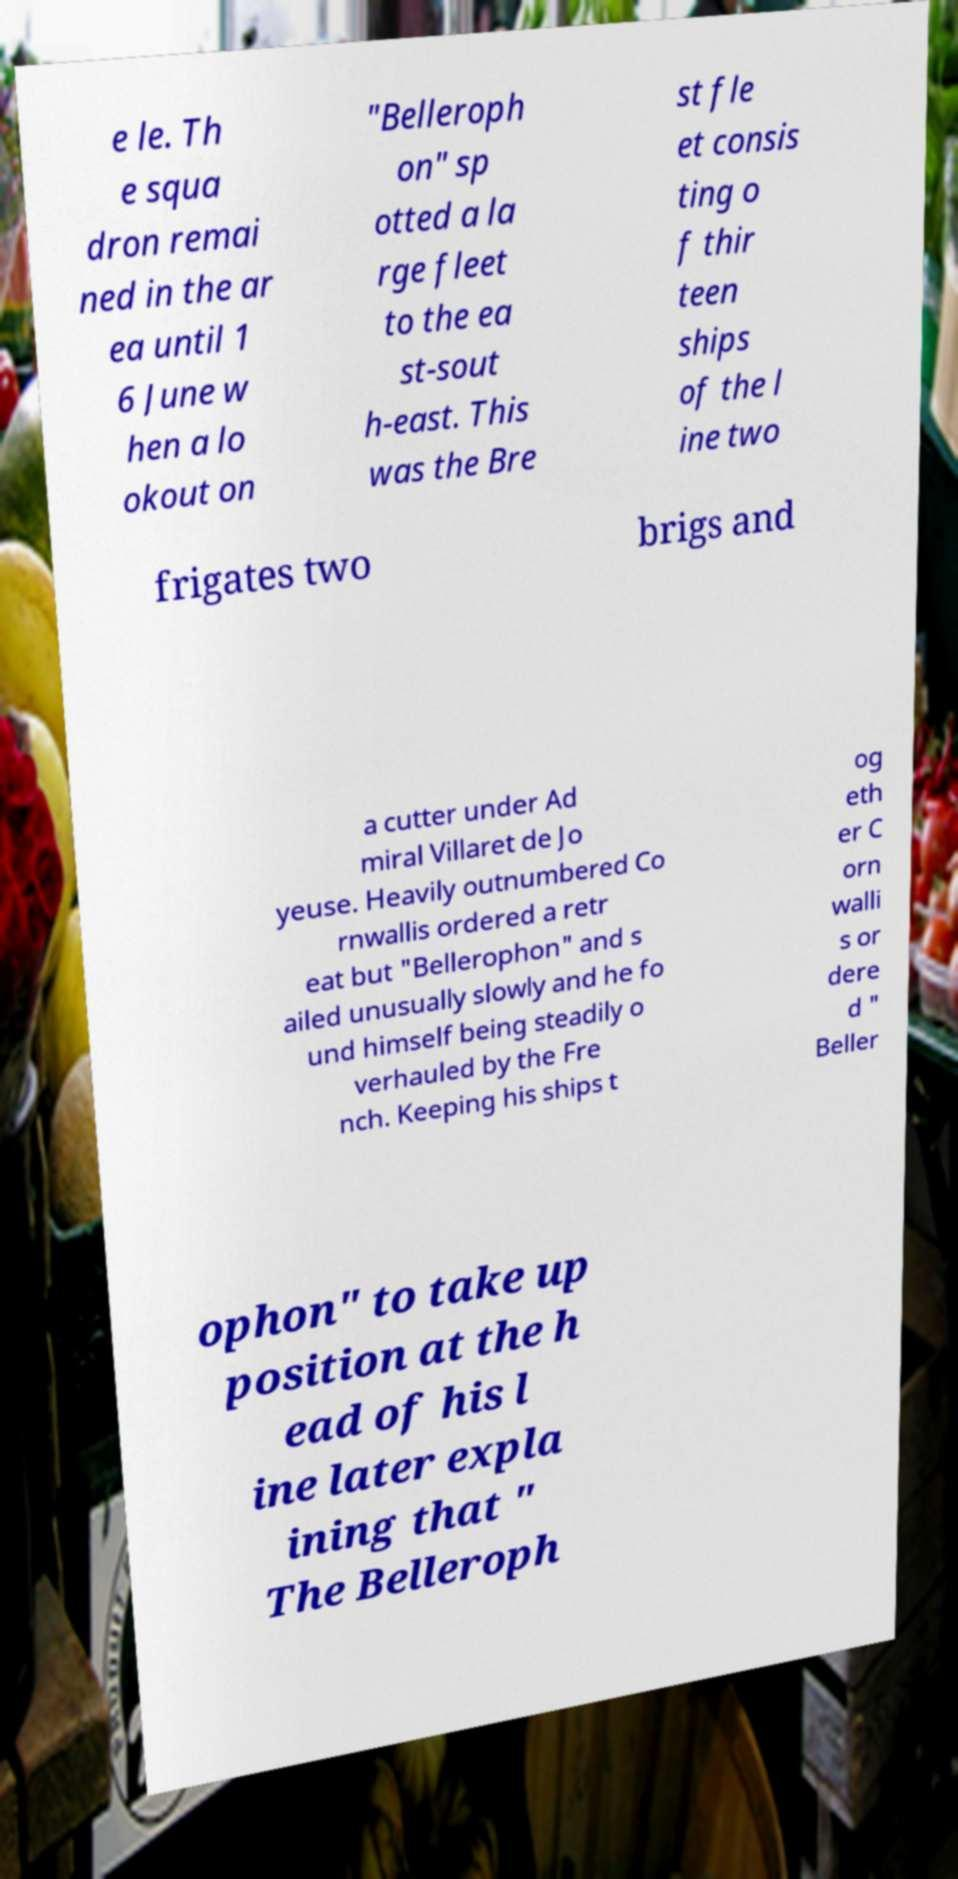Can you read and provide the text displayed in the image?This photo seems to have some interesting text. Can you extract and type it out for me? e le. Th e squa dron remai ned in the ar ea until 1 6 June w hen a lo okout on "Belleroph on" sp otted a la rge fleet to the ea st-sout h-east. This was the Bre st fle et consis ting o f thir teen ships of the l ine two frigates two brigs and a cutter under Ad miral Villaret de Jo yeuse. Heavily outnumbered Co rnwallis ordered a retr eat but "Bellerophon" and s ailed unusually slowly and he fo und himself being steadily o verhauled by the Fre nch. Keeping his ships t og eth er C orn walli s or dere d " Beller ophon" to take up position at the h ead of his l ine later expla ining that " The Belleroph 